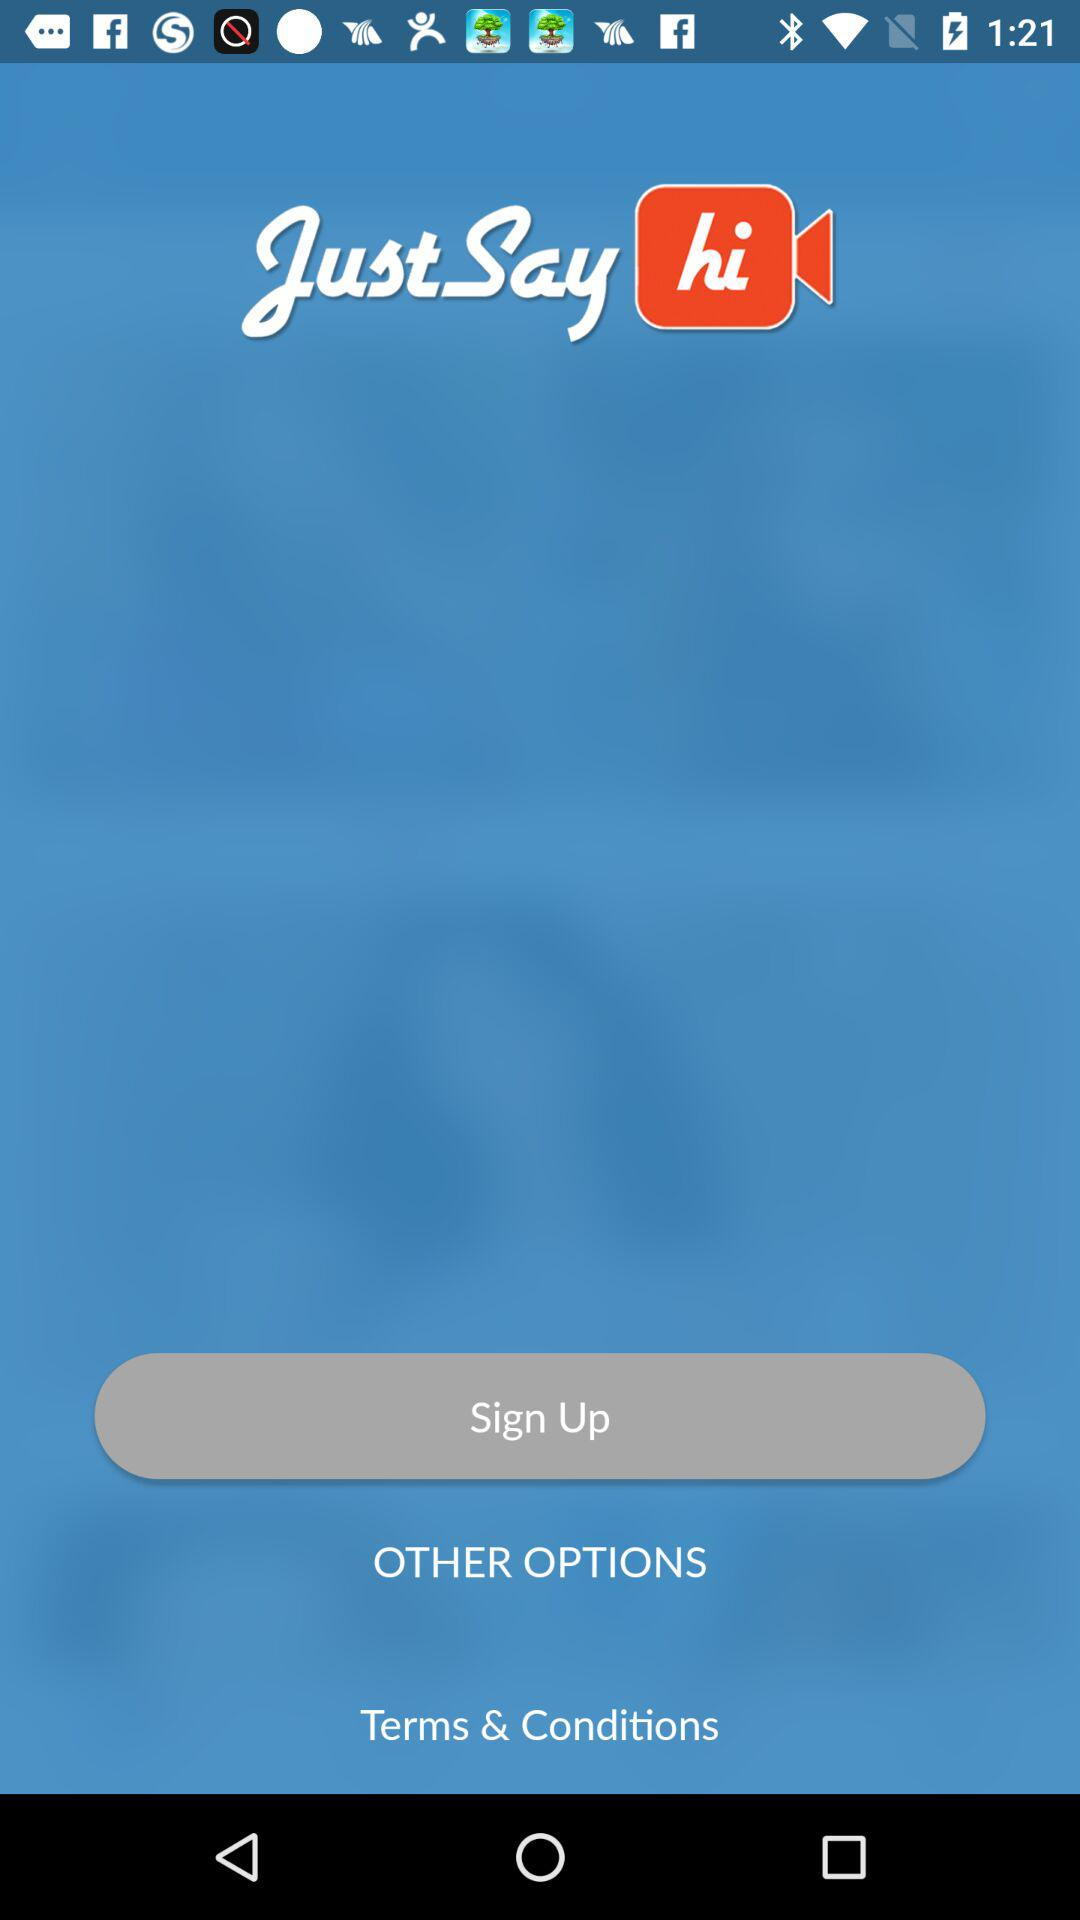What is the app's title? The app's title is "JustSay hi". 